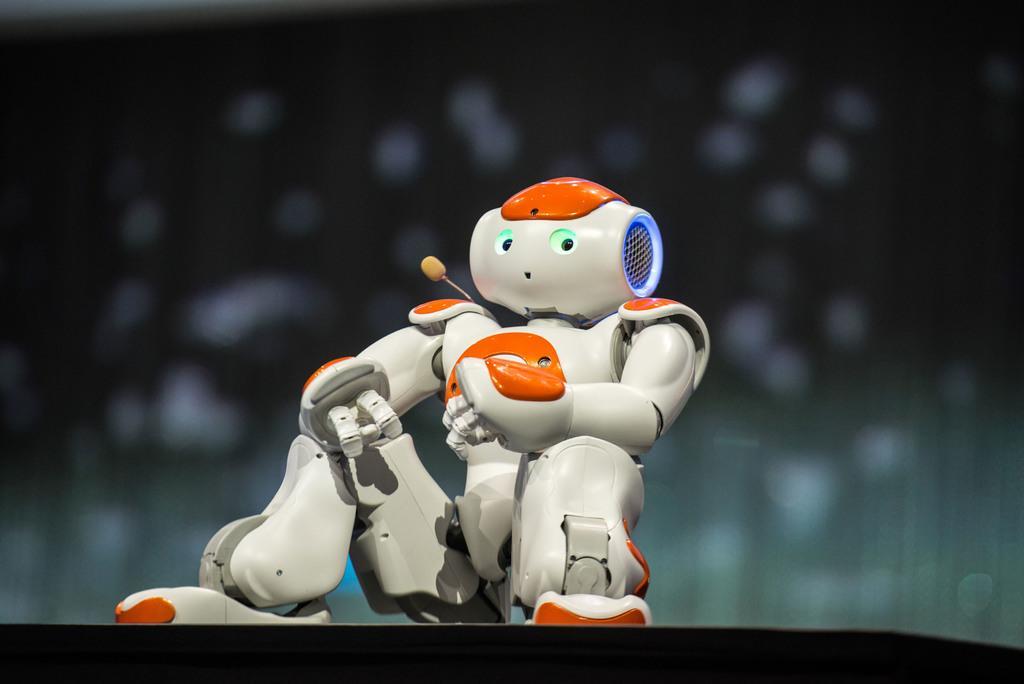Can you describe this image briefly? In the center of the image we can see robot. 